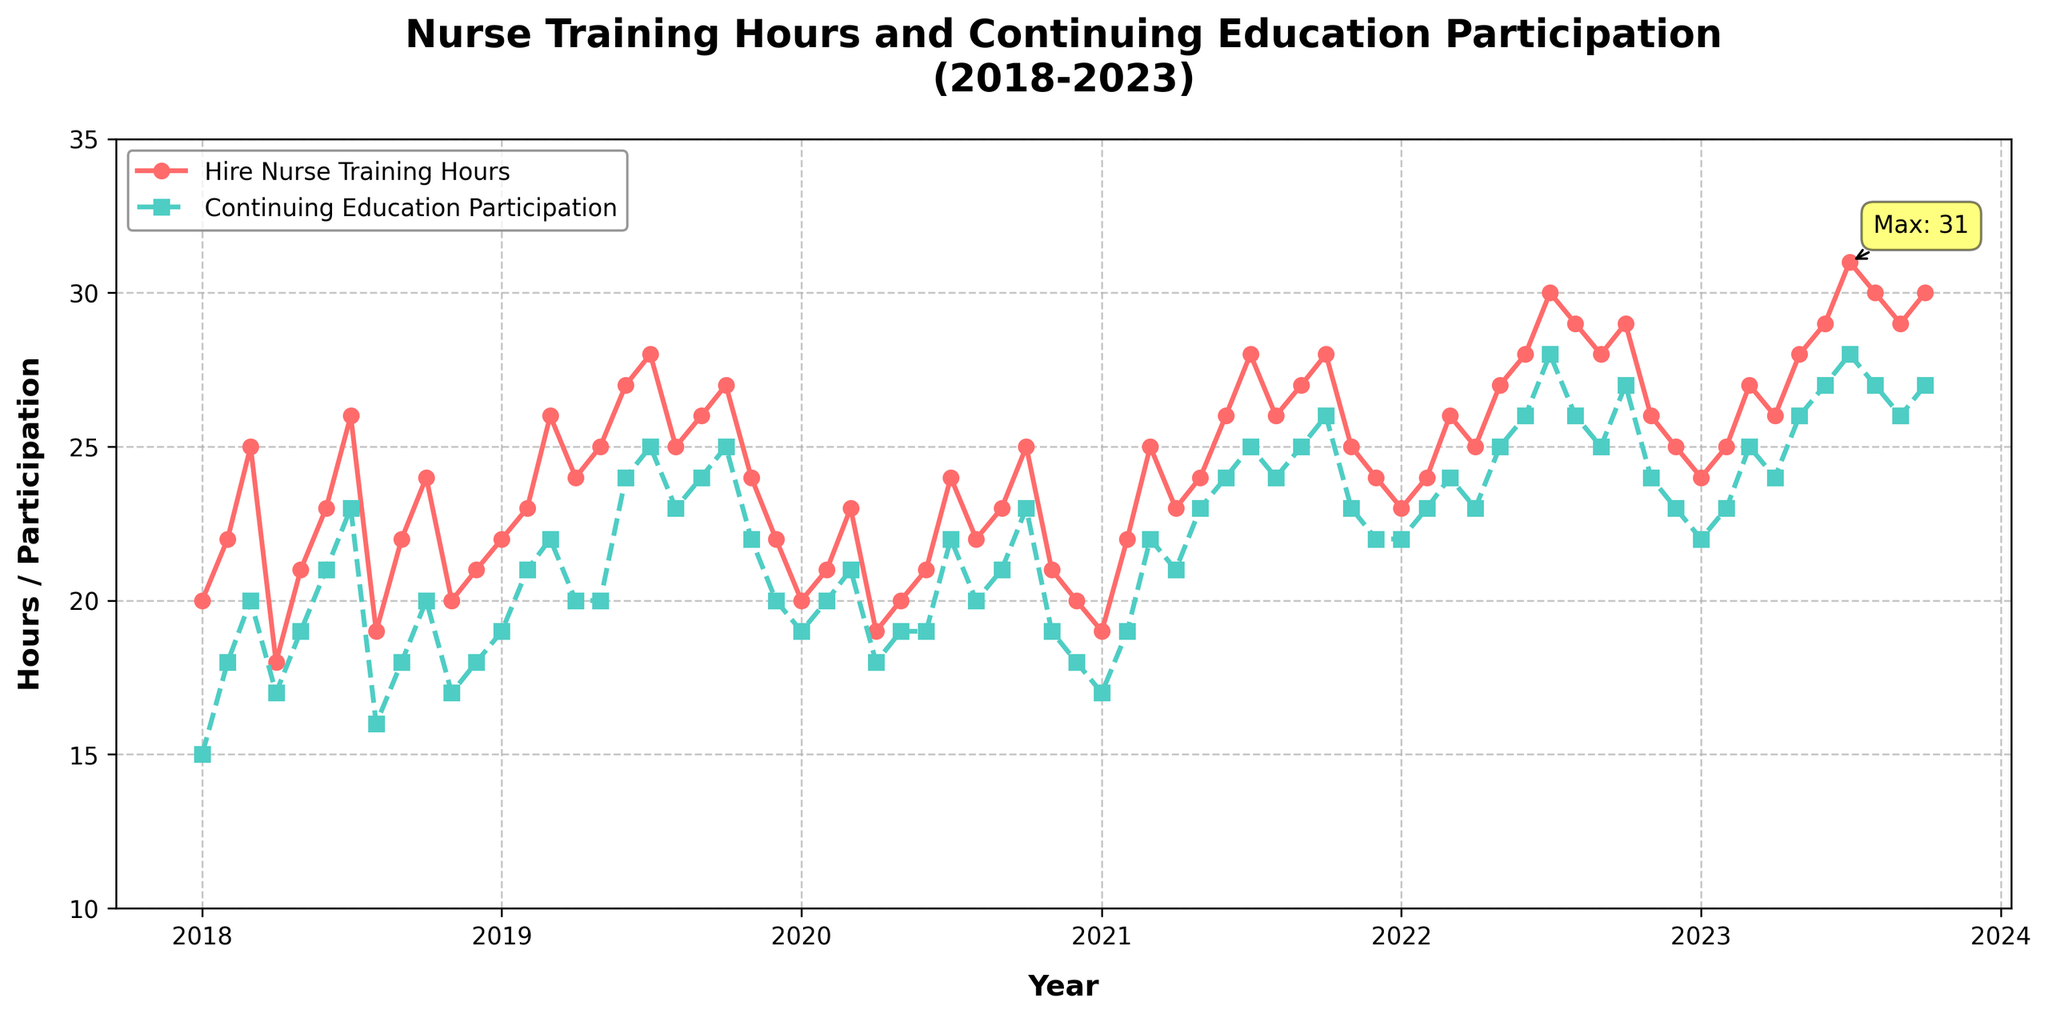How many unique years are displayed in the plot? The x-axis of the plot is labeled with years from 2018 to 2023. Counting these years gives us the number of unique years.
Answer: 6 What is the title of the plot? The title of the plot is displayed at the top and reads "Nurse Training Hours and Continuing Education Participation (2018-2023)".
Answer: Nurse Training Hours and Continuing Education Participation (2018-2023) Which month and year had the maximum hire nurse training hours, and what is that value? The plot contains an annotation highlighting the maximum hire nurse training hours. This annotation can be found near the data point for July 2023, indicating a value of 31 hours.
Answer: July 2023, 31 How does the trend in continuing education participation compare to hire nurse training hours over time? By following the lines and markers representing each category (solid line for hire nurse training hours and dashed line for continuing education participation), we can observe that both trends generally increase over time. However, hire nurse training hours have slightly more fluctuation compared to continuing education.
Answer: Both generally increase; hire nurse training hours fluctuate more What is the average hire nurse training hours in the year 2021? To find the average hire nurse training hours in 2021, locate and sum the values for each month of that year (19, 22, 25, 23, 24, 26, 28, 26, 27, 28, 25, 24) and then divide by 12. The sum is 297, and the average is 297/12.
Answer: 24.75 During which months in 2022 did the hire nurse training hours reach 30 or more? By reviewing the plot for 2022 and looking at the hire nurse training hours (solid line), we see two points where the value reaches 30 or more: July (30) and August (29, close to 30 but slightly less).
Answer: July 2022 What was the continuing education participation in March 2020? Find the dashed line data point for March 2020 on the plot, which corresponds to the continuing education participation value of 21.
Answer: 21 Which year showed the highest growth in hire nurse training hours from January to December? Compare the increase from January to December for each year. The highest growth can be seen in 2023, with hire nurse training hours increasing from 24 in January to 30 in October, a growth of 6.
Answer: 2023 How many times did the continuing education participation rate reach or exceed 25 between 2018 and 2023? Count all instances where the dashed line reaches or exceeds the value of 25 between 2018 and 2023. There are five such points: July 2019, July 2021, October 2021, July 2022, and May to October 2023.
Answer: 5 